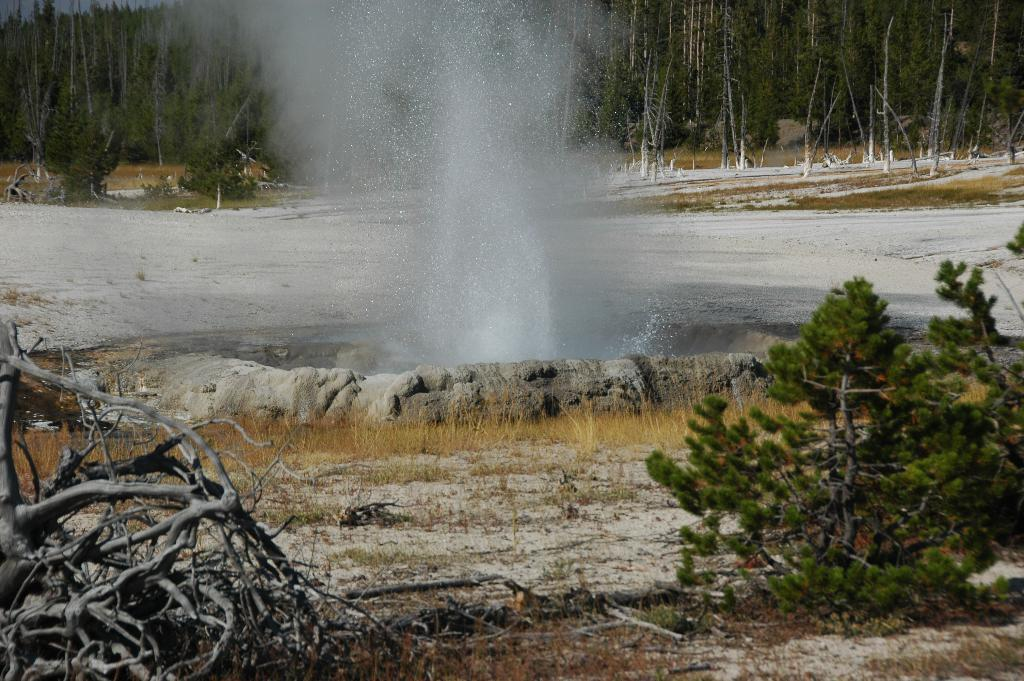What is the main subject of the picture? The main subject of the picture is a hot spring. What can be seen inside the hot spring? There is water in the hot spring. What type of natural environment is visible in the background of the picture? There are trees in the background of the picture. How many lizards are sitting on the coat in the image? There are no lizards or coats present in the image; it features a hot spring with water and trees in the background. What type of baseball equipment can be seen in the image? There is no baseball equipment present in the image. 